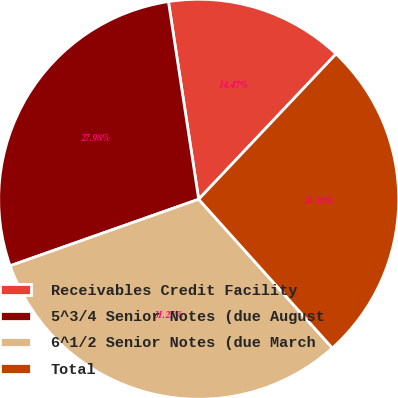<chart> <loc_0><loc_0><loc_500><loc_500><pie_chart><fcel>Receivables Credit Facility<fcel>5^3/4 Senior Notes (due August<fcel>6^1/2 Senior Notes (due March<fcel>Total<nl><fcel>14.47%<fcel>27.98%<fcel>31.25%<fcel>26.3%<nl></chart> 